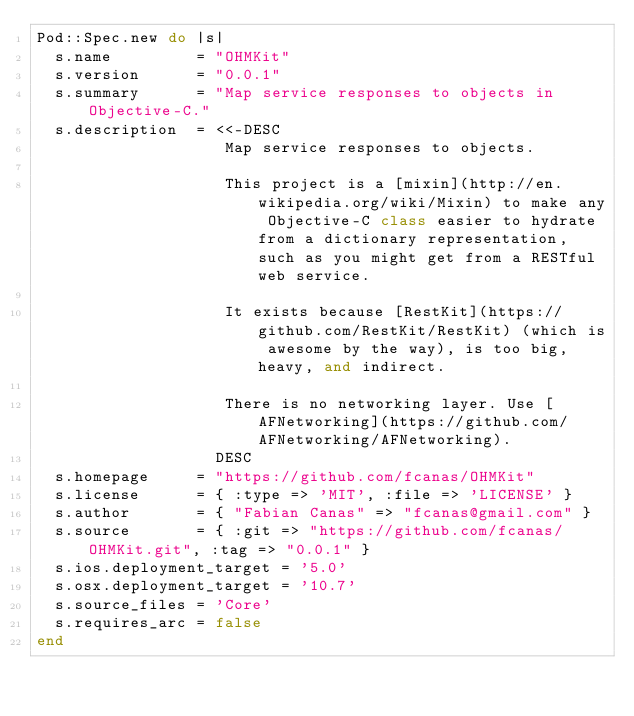Convert code to text. <code><loc_0><loc_0><loc_500><loc_500><_Ruby_>Pod::Spec.new do |s|
  s.name         = "OHMKit"
  s.version      = "0.0.1"
  s.summary      = "Map service responses to objects in Objective-C."
  s.description  = <<-DESC
                    Map service responses to objects.

                    This project is a [mixin](http://en.wikipedia.org/wiki/Mixin) to make any Objective-C class easier to hydrate from a dictionary representation, such as you might get from a RESTful web service.

                    It exists because [RestKit](https://github.com/RestKit/RestKit) (which is awesome by the way), is too big, heavy, and indirect.

                    There is no networking layer. Use [AFNetworking](https://github.com/AFNetworking/AFNetworking).
                   DESC
  s.homepage     = "https://github.com/fcanas/OHMKit"
  s.license      = { :type => 'MIT', :file => 'LICENSE' }
  s.author       = { "Fabian Canas" => "fcanas@gmail.com" }
  s.source       = { :git => "https://github.com/fcanas/OHMKit.git", :tag => "0.0.1" }
  s.ios.deployment_target = '5.0'
  s.osx.deployment_target = '10.7'
  s.source_files = 'Core'
  s.requires_arc = false
end
</code> 